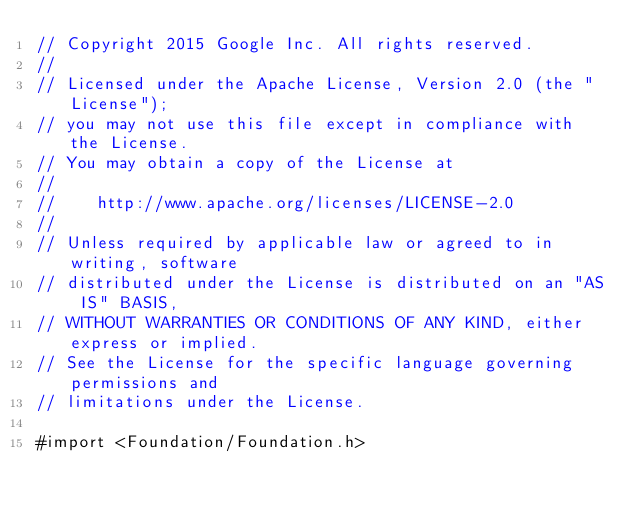<code> <loc_0><loc_0><loc_500><loc_500><_ObjectiveC_>// Copyright 2015 Google Inc. All rights reserved.
//
// Licensed under the Apache License, Version 2.0 (the "License");
// you may not use this file except in compliance with the License.
// You may obtain a copy of the License at
//
//    http://www.apache.org/licenses/LICENSE-2.0
//
// Unless required by applicable law or agreed to in writing, software
// distributed under the License is distributed on an "AS IS" BASIS,
// WITHOUT WARRANTIES OR CONDITIONS OF ANY KIND, either express or implied.
// See the License for the specific language governing permissions and
// limitations under the License.

#import <Foundation/Foundation.h>
</code> 